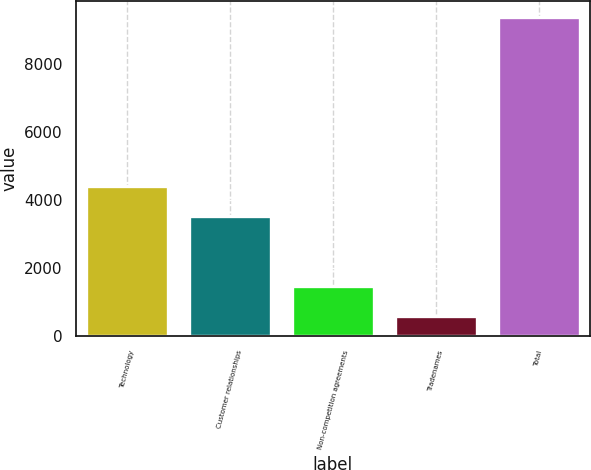Convert chart. <chart><loc_0><loc_0><loc_500><loc_500><bar_chart><fcel>Technology<fcel>Customer relationships<fcel>Non-competition agreements<fcel>Tradenames<fcel>Total<nl><fcel>4410<fcel>3530<fcel>1470<fcel>590<fcel>9390<nl></chart> 